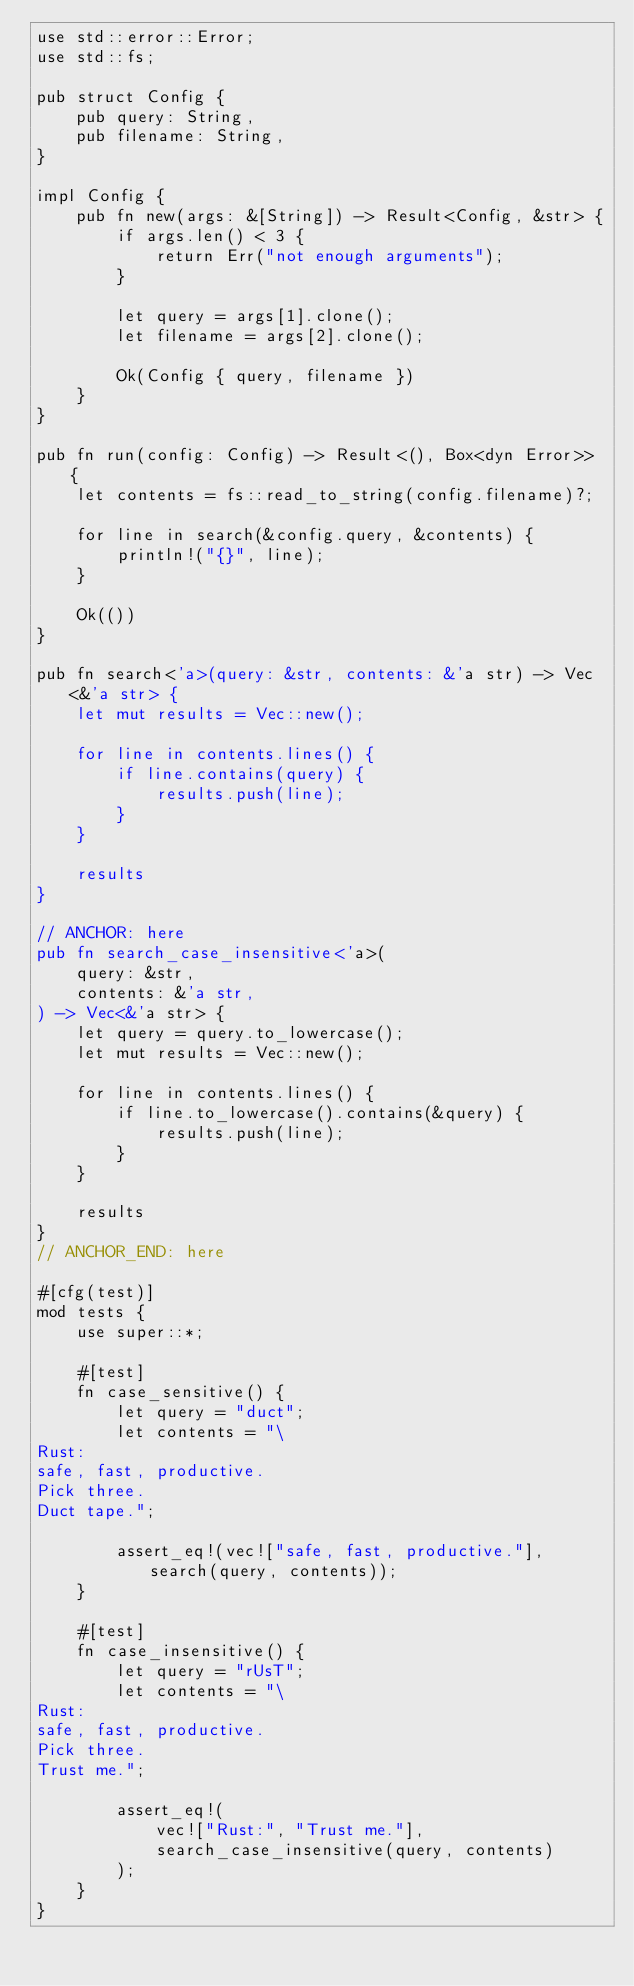Convert code to text. <code><loc_0><loc_0><loc_500><loc_500><_Rust_>use std::error::Error;
use std::fs;

pub struct Config {
    pub query: String,
    pub filename: String,
}

impl Config {
    pub fn new(args: &[String]) -> Result<Config, &str> {
        if args.len() < 3 {
            return Err("not enough arguments");
        }

        let query = args[1].clone();
        let filename = args[2].clone();

        Ok(Config { query, filename })
    }
}

pub fn run(config: Config) -> Result<(), Box<dyn Error>> {
    let contents = fs::read_to_string(config.filename)?;

    for line in search(&config.query, &contents) {
        println!("{}", line);
    }

    Ok(())
}

pub fn search<'a>(query: &str, contents: &'a str) -> Vec<&'a str> {
    let mut results = Vec::new();

    for line in contents.lines() {
        if line.contains(query) {
            results.push(line);
        }
    }

    results
}

// ANCHOR: here
pub fn search_case_insensitive<'a>(
    query: &str,
    contents: &'a str,
) -> Vec<&'a str> {
    let query = query.to_lowercase();
    let mut results = Vec::new();

    for line in contents.lines() {
        if line.to_lowercase().contains(&query) {
            results.push(line);
        }
    }

    results
}
// ANCHOR_END: here

#[cfg(test)]
mod tests {
    use super::*;

    #[test]
    fn case_sensitive() {
        let query = "duct";
        let contents = "\
Rust:
safe, fast, productive.
Pick three.
Duct tape.";

        assert_eq!(vec!["safe, fast, productive."], search(query, contents));
    }

    #[test]
    fn case_insensitive() {
        let query = "rUsT";
        let contents = "\
Rust:
safe, fast, productive.
Pick three.
Trust me.";

        assert_eq!(
            vec!["Rust:", "Trust me."],
            search_case_insensitive(query, contents)
        );
    }
}
</code> 